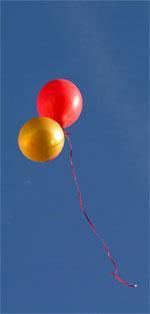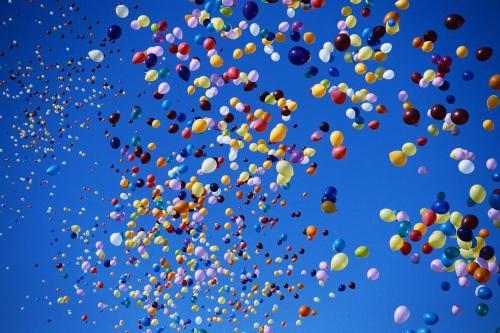The first image is the image on the left, the second image is the image on the right. For the images shown, is this caption "The left image features a string-tied 'bunch' of no more than ten balloons, and the right image shows balloons scattered across the sky." true? Answer yes or no. Yes. The first image is the image on the left, the second image is the image on the right. For the images displayed, is the sentence "More than 50 individual loose balloons float up into the sky." factually correct? Answer yes or no. Yes. 